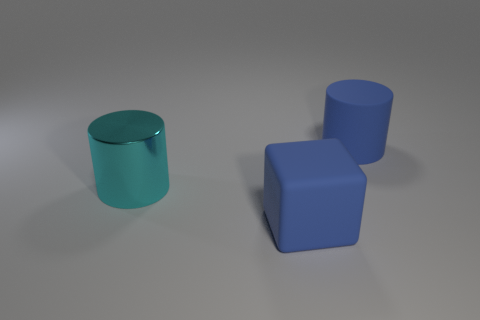Add 2 big cyan objects. How many objects exist? 5 Subtract all cylinders. How many objects are left? 1 Add 1 cyan objects. How many cyan objects exist? 2 Subtract 0 gray cylinders. How many objects are left? 3 Subtract all cyan metallic things. Subtract all big brown metallic things. How many objects are left? 2 Add 3 big blue rubber cylinders. How many big blue rubber cylinders are left? 4 